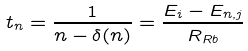Convert formula to latex. <formula><loc_0><loc_0><loc_500><loc_500>t _ { n } = \frac { 1 } { n - \delta ( n ) } = \frac { E _ { i } - E _ { n , j } } { R _ { R b } }</formula> 